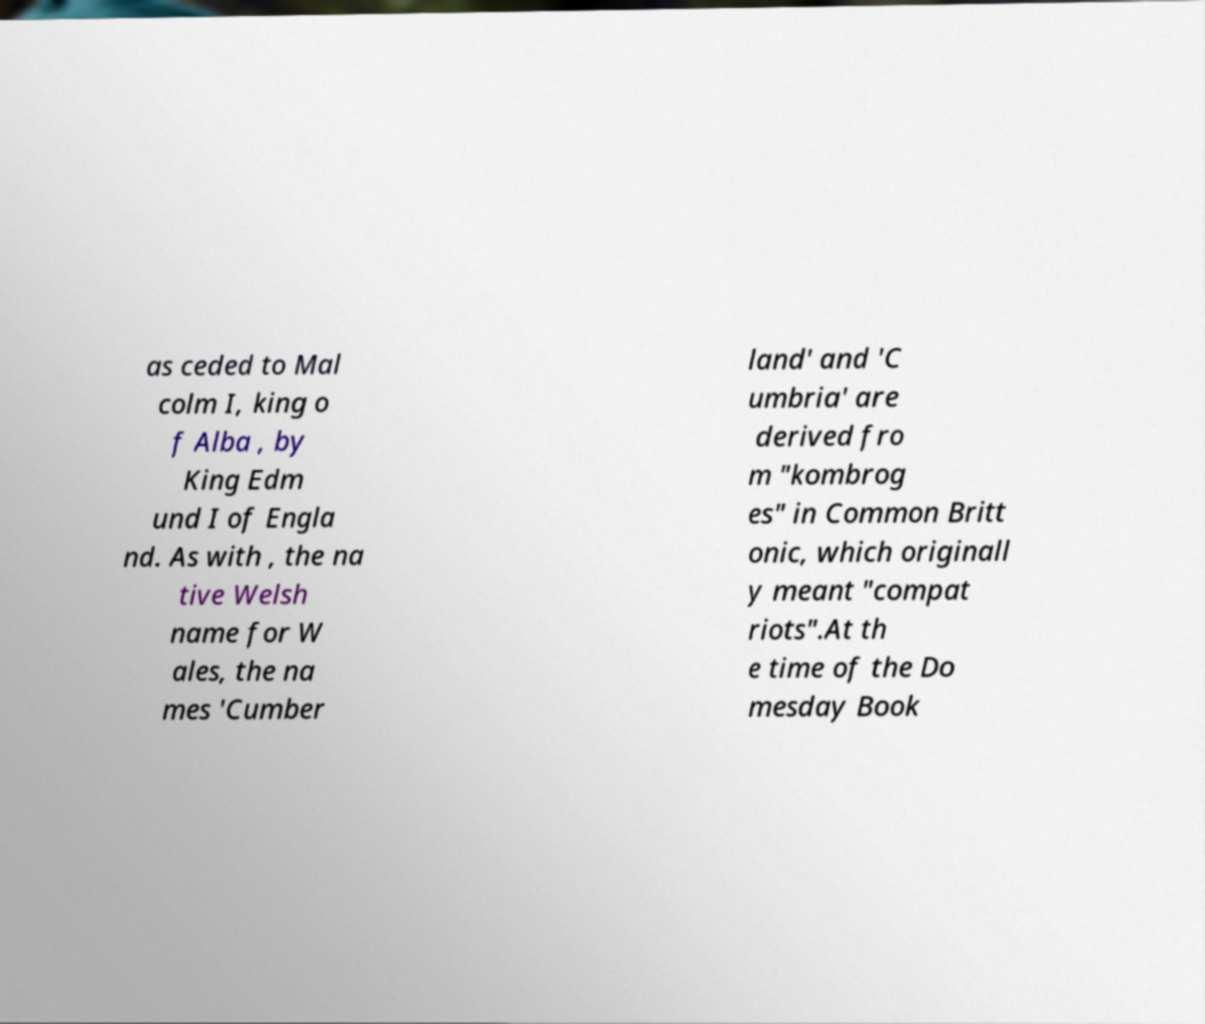What messages or text are displayed in this image? I need them in a readable, typed format. as ceded to Mal colm I, king o f Alba , by King Edm und I of Engla nd. As with , the na tive Welsh name for W ales, the na mes 'Cumber land' and 'C umbria' are derived fro m "kombrog es" in Common Britt onic, which originall y meant "compat riots".At th e time of the Do mesday Book 